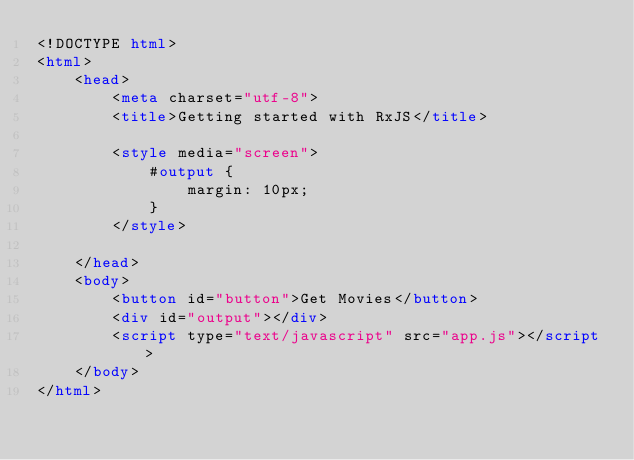Convert code to text. <code><loc_0><loc_0><loc_500><loc_500><_HTML_><!DOCTYPE html>
<html>
    <head>
        <meta charset="utf-8">
        <title>Getting started with RxJS</title>

        <style media="screen">
            #output {
                margin: 10px;
            }
        </style>

    </head>
    <body>
        <button id="button">Get Movies</button>
        <div id="output"></div>
        <script type="text/javascript" src="app.js"></script>
    </body>
</html>
</code> 